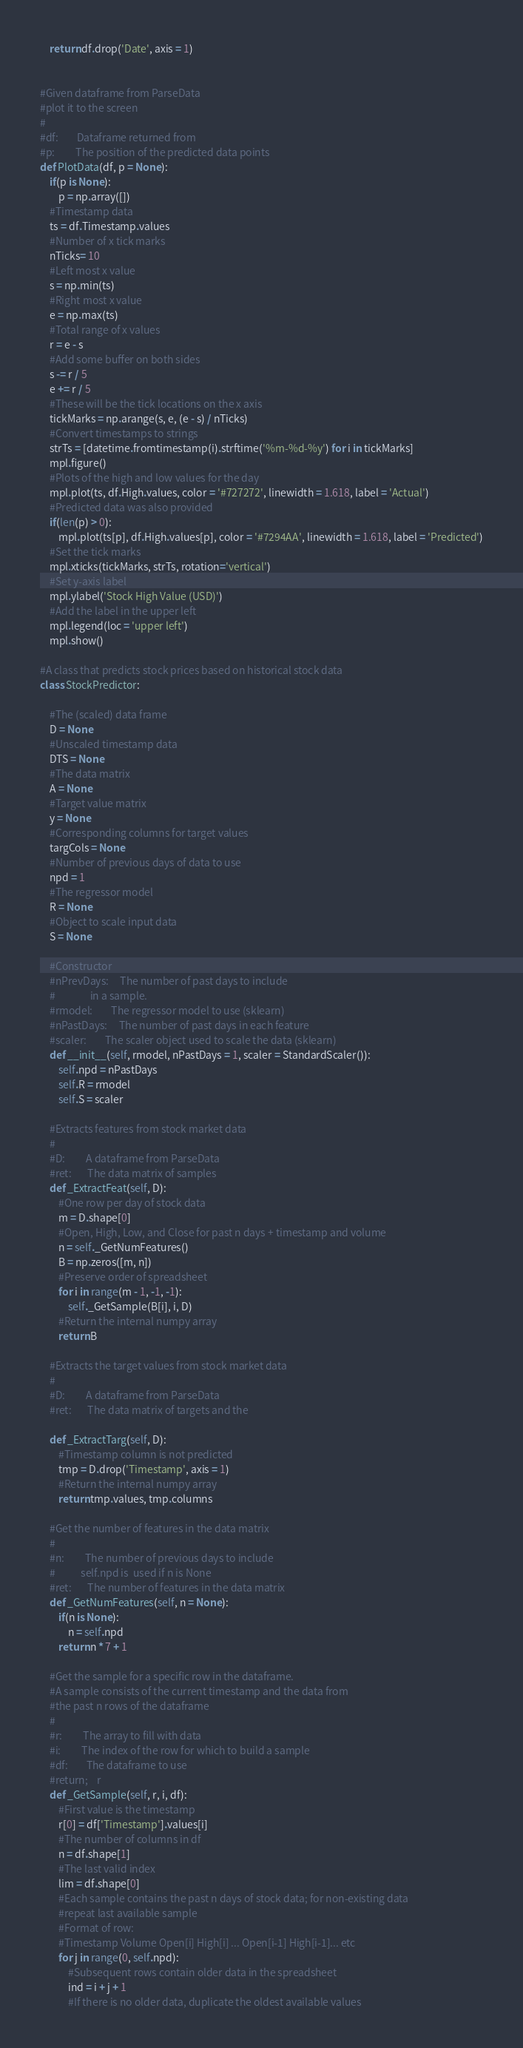<code> <loc_0><loc_0><loc_500><loc_500><_Python_>    return df.drop('Date', axis = 1) 
    
        
#Given dataframe from ParseData
#plot it to the screen
#
#df:        Dataframe returned from 
#p:         The position of the predicted data points
def PlotData(df, p = None):
    if(p is None):
        p = np.array([])
    #Timestamp data
    ts = df.Timestamp.values
    #Number of x tick marks
    nTicks= 10
    #Left most x value
    s = np.min(ts)
    #Right most x value
    e = np.max(ts)
    #Total range of x values
    r = e - s
    #Add some buffer on both sides
    s -= r / 5
    e += r / 5
    #These will be the tick locations on the x axis
    tickMarks = np.arange(s, e, (e - s) / nTicks)
    #Convert timestamps to strings
    strTs = [datetime.fromtimestamp(i).strftime('%m-%d-%y') for i in tickMarks]
    mpl.figure()
    #Plots of the high and low values for the day
    mpl.plot(ts, df.High.values, color = '#727272', linewidth = 1.618, label = 'Actual')
    #Predicted data was also provided
    if(len(p) > 0):
        mpl.plot(ts[p], df.High.values[p], color = '#7294AA', linewidth = 1.618, label = 'Predicted')
    #Set the tick marks
    mpl.xticks(tickMarks, strTs, rotation='vertical')
    #Set y-axis label
    mpl.ylabel('Stock High Value (USD)')
    #Add the label in the upper left
    mpl.legend(loc = 'upper left')
    mpl.show()

#A class that predicts stock prices based on historical stock data
class StockPredictor:
    
    #The (scaled) data frame
    D = None
    #Unscaled timestamp data
    DTS = None
    #The data matrix
    A = None
    #Target value matrix
    y = None
    #Corresponding columns for target values
    targCols = None
    #Number of previous days of data to use
    npd = 1
    #The regressor model
    R = None
    #Object to scale input data
    S = None
    
    #Constructor
    #nPrevDays:     The number of past days to include
    #               in a sample.
    #rmodel:        The regressor model to use (sklearn)
    #nPastDays:     The number of past days in each feature
    #scaler:        The scaler object used to scale the data (sklearn)
    def __init__(self, rmodel, nPastDays = 1, scaler = StandardScaler()):
        self.npd = nPastDays
        self.R = rmodel
        self.S = scaler
        
    #Extracts features from stock market data
    #
    #D:         A dataframe from ParseData
    #ret:       The data matrix of samples
    def _ExtractFeat(self, D):
        #One row per day of stock data
        m = D.shape[0]
        #Open, High, Low, and Close for past n days + timestamp and volume
        n = self._GetNumFeatures()
        B = np.zeros([m, n])
        #Preserve order of spreadsheet
        for i in range(m - 1, -1, -1):
            self._GetSample(B[i], i, D)
        #Return the internal numpy array
        return B
        
    #Extracts the target values from stock market data
    #
    #D:         A dataframe from ParseData
    #ret:       The data matrix of targets and the
    
    def _ExtractTarg(self, D):
        #Timestamp column is not predicted
        tmp = D.drop('Timestamp', axis = 1)
        #Return the internal numpy array
        return tmp.values, tmp.columns
        
    #Get the number of features in the data matrix
    #
    #n:         The number of previous days to include
    #           self.npd is  used if n is None
    #ret:       The number of features in the data matrix
    def _GetNumFeatures(self, n = None):
        if(n is None):
            n = self.npd
        return n * 7 + 1
        
    #Get the sample for a specific row in the dataframe. 
    #A sample consists of the current timestamp and the data from
    #the past n rows of the dataframe
    #
    #r:         The array to fill with data
    #i:         The index of the row for which to build a sample
    #df:        The dataframe to use
    #return;    r
    def _GetSample(self, r, i, df):
        #First value is the timestamp
        r[0] = df['Timestamp'].values[i]
        #The number of columns in df
        n = df.shape[1]
        #The last valid index
        lim = df.shape[0]
        #Each sample contains the past n days of stock data; for non-existing data
        #repeat last available sample
        #Format of row:
        #Timestamp Volume Open[i] High[i] ... Open[i-1] High[i-1]... etc
        for j in range(0, self.npd):
            #Subsequent rows contain older data in the spreadsheet
            ind = i + j + 1
            #If there is no older data, duplicate the oldest available values</code> 